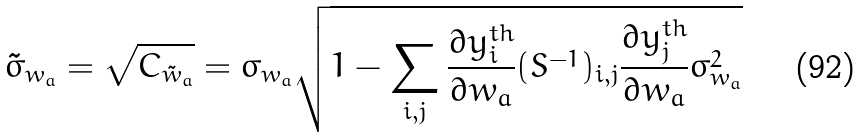<formula> <loc_0><loc_0><loc_500><loc_500>\tilde { \sigma } _ { w _ { a } } = \sqrt { C _ { \tilde { w } _ { a } } } = \sigma _ { w _ { a } } \sqrt { 1 - \sum _ { i , j } \frac { \partial y _ { i } ^ { t h } } { \partial w _ { a } } ( S ^ { - 1 } ) _ { i , j } \frac { \partial y _ { j } ^ { t h } } { \partial w _ { a } } \sigma _ { w _ { a } } ^ { 2 } }</formula> 